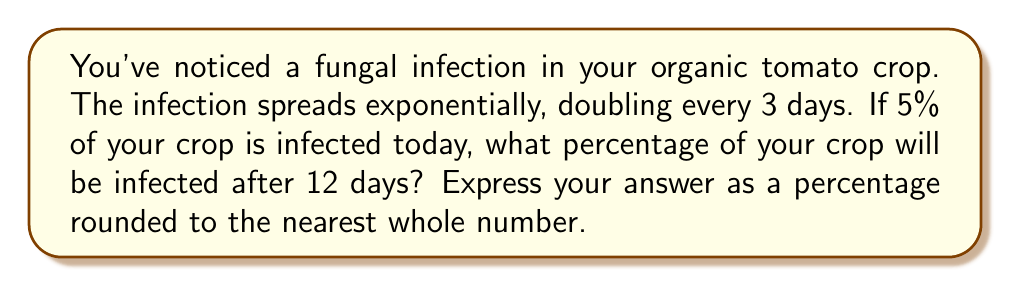Solve this math problem. Let's approach this step-by-step:

1) First, we need to identify the initial value and the growth rate:
   - Initial infection: 5% = 0.05
   - Doubling time: 3 days
   - Time period: 12 days

2) We can use the exponential growth formula:
   $A = P(1 + r)^t$
   Where:
   $A$ = final amount
   $P$ = initial amount
   $r$ = growth rate per unit time
   $t$ = number of time units

3) We need to find $r$. If the population doubles every 3 days, we can set up this equation:
   $2 = (1 + r)^3$

4) Solving for $r$:
   $\sqrt[3]{2} = 1 + r$
   $r = \sqrt[3]{2} - 1 \approx 0.2599$ or about 26% per 3-day period

5) Now we can set up our main equation:
   $A = 0.05(1 + 0.2599)^{12/3}$

6) Simplify:
   $A = 0.05(1.2599)^4$

7) Calculate:
   $A = 0.05 * 2.5198 = 0.12599$

8) Convert to percentage and round:
   $0.12599 * 100 \approx 13\%$
Answer: 13% 